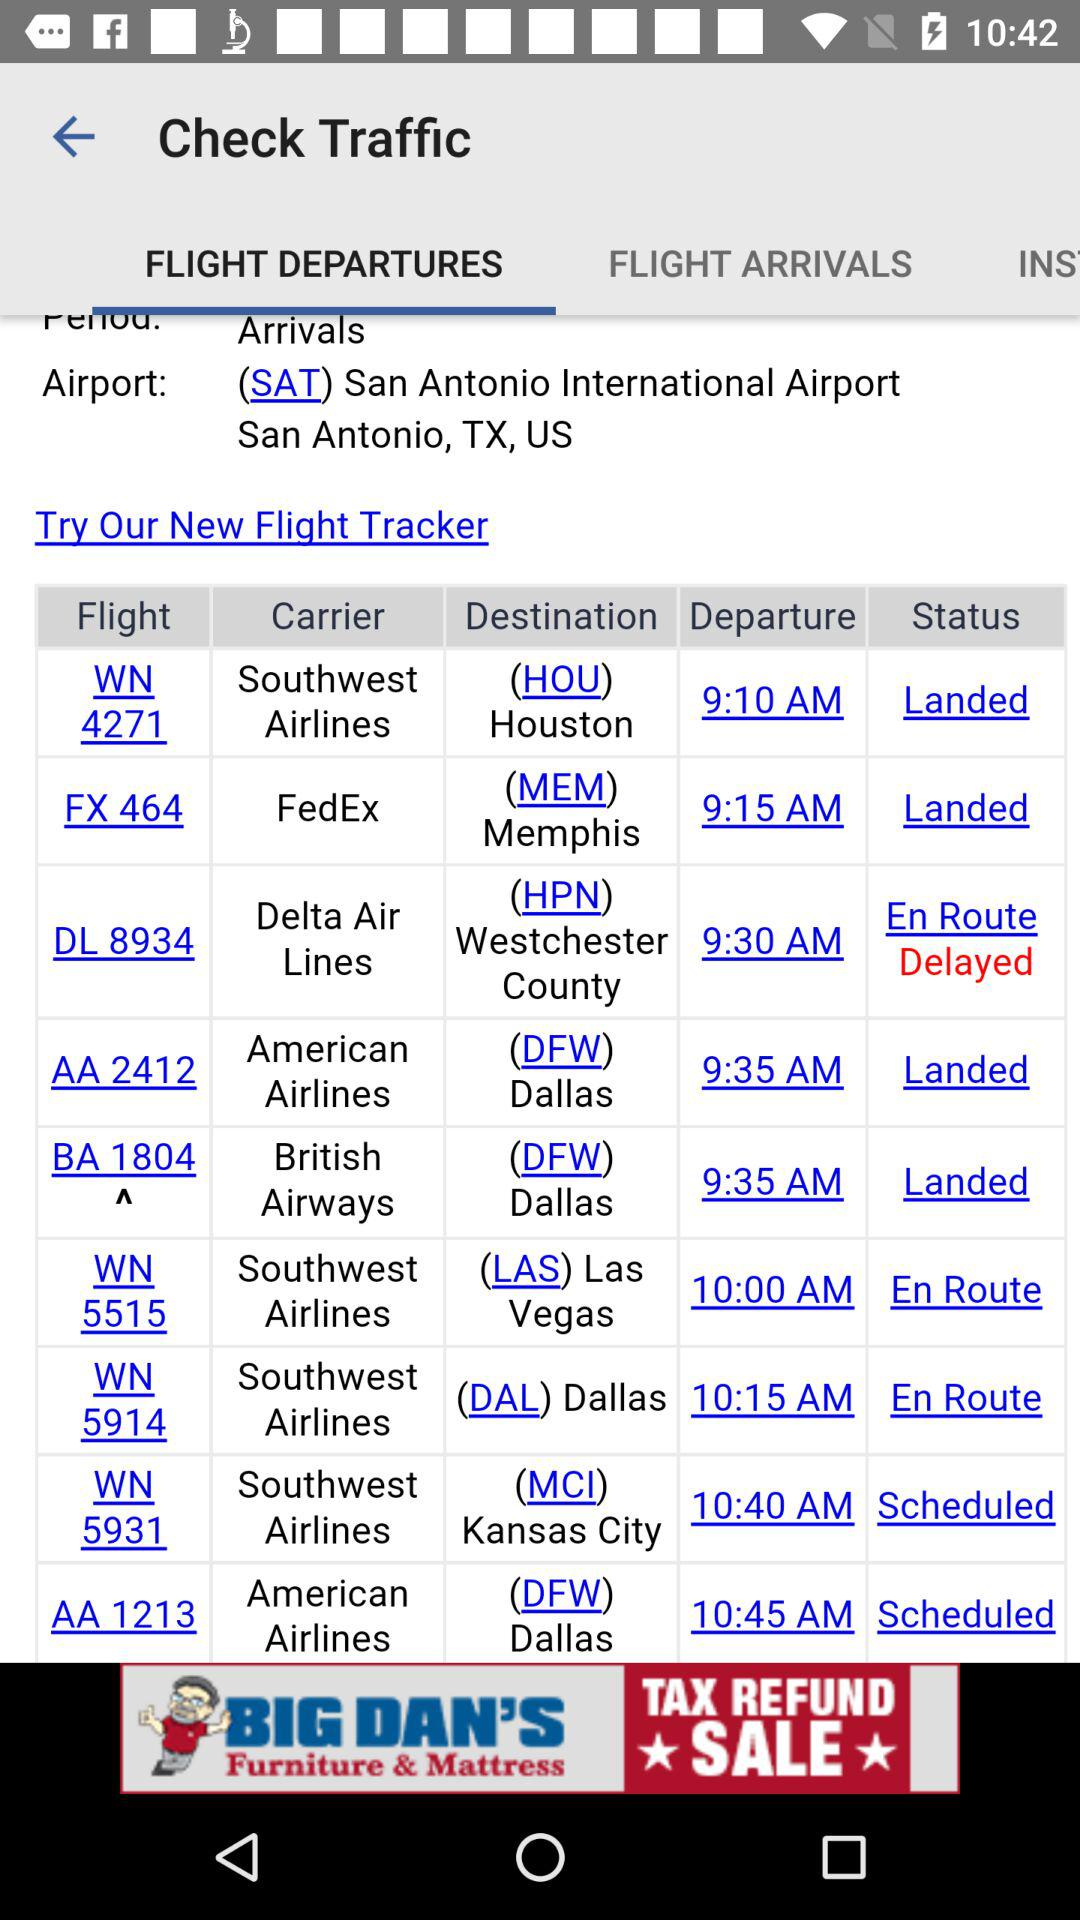Who is the carrier for WN 5515? The carrier for WN 5515 is Southwest Airlines. 